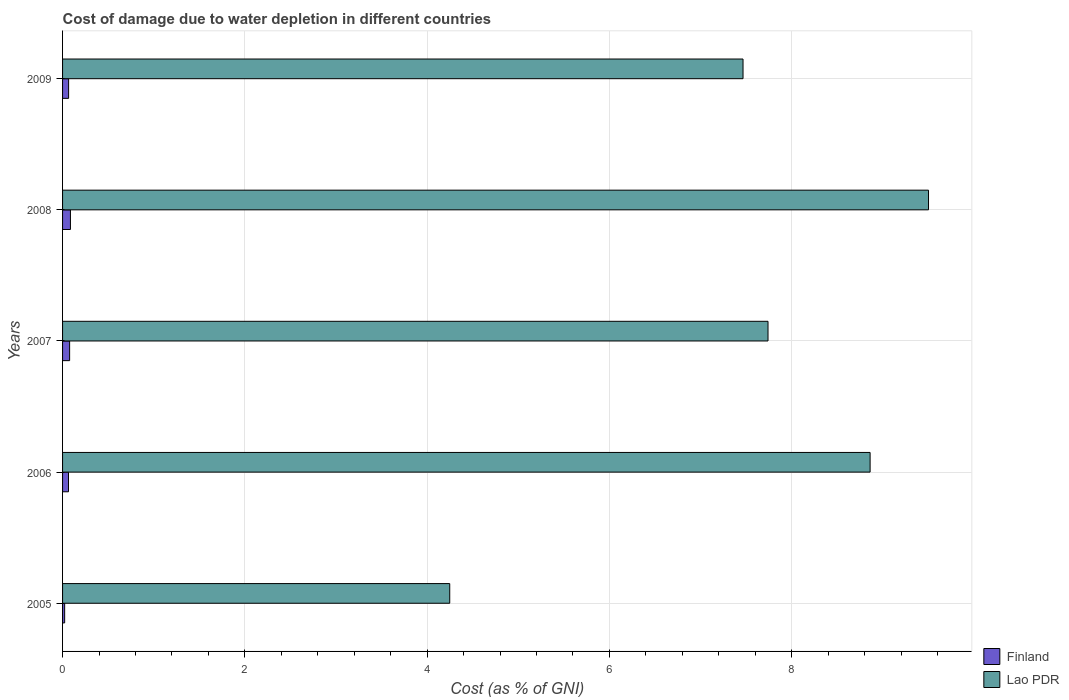How many different coloured bars are there?
Provide a short and direct response. 2. Are the number of bars per tick equal to the number of legend labels?
Offer a terse response. Yes. What is the label of the 4th group of bars from the top?
Offer a very short reply. 2006. In how many cases, is the number of bars for a given year not equal to the number of legend labels?
Keep it short and to the point. 0. What is the cost of damage caused due to water depletion in Lao PDR in 2007?
Make the answer very short. 7.74. Across all years, what is the maximum cost of damage caused due to water depletion in Lao PDR?
Offer a very short reply. 9.5. Across all years, what is the minimum cost of damage caused due to water depletion in Lao PDR?
Give a very brief answer. 4.25. In which year was the cost of damage caused due to water depletion in Lao PDR minimum?
Ensure brevity in your answer.  2005. What is the total cost of damage caused due to water depletion in Lao PDR in the graph?
Your response must be concise. 37.82. What is the difference between the cost of damage caused due to water depletion in Finland in 2005 and that in 2006?
Your answer should be very brief. -0.04. What is the difference between the cost of damage caused due to water depletion in Lao PDR in 2006 and the cost of damage caused due to water depletion in Finland in 2008?
Ensure brevity in your answer.  8.77. What is the average cost of damage caused due to water depletion in Finland per year?
Give a very brief answer. 0.06. In the year 2008, what is the difference between the cost of damage caused due to water depletion in Finland and cost of damage caused due to water depletion in Lao PDR?
Give a very brief answer. -9.42. What is the ratio of the cost of damage caused due to water depletion in Lao PDR in 2006 to that in 2007?
Your answer should be compact. 1.14. Is the cost of damage caused due to water depletion in Finland in 2005 less than that in 2009?
Provide a short and direct response. Yes. What is the difference between the highest and the second highest cost of damage caused due to water depletion in Finland?
Provide a succinct answer. 0.01. What is the difference between the highest and the lowest cost of damage caused due to water depletion in Lao PDR?
Make the answer very short. 5.25. In how many years, is the cost of damage caused due to water depletion in Finland greater than the average cost of damage caused due to water depletion in Finland taken over all years?
Your answer should be very brief. 4. Is the sum of the cost of damage caused due to water depletion in Lao PDR in 2005 and 2008 greater than the maximum cost of damage caused due to water depletion in Finland across all years?
Your answer should be very brief. Yes. What does the 1st bar from the top in 2008 represents?
Your response must be concise. Lao PDR. What does the 1st bar from the bottom in 2006 represents?
Keep it short and to the point. Finland. How many bars are there?
Your answer should be very brief. 10. How many years are there in the graph?
Make the answer very short. 5. Are the values on the major ticks of X-axis written in scientific E-notation?
Ensure brevity in your answer.  No. Does the graph contain any zero values?
Ensure brevity in your answer.  No. Does the graph contain grids?
Keep it short and to the point. Yes. How many legend labels are there?
Keep it short and to the point. 2. What is the title of the graph?
Your response must be concise. Cost of damage due to water depletion in different countries. Does "Sudan" appear as one of the legend labels in the graph?
Offer a very short reply. No. What is the label or title of the X-axis?
Your answer should be very brief. Cost (as % of GNI). What is the label or title of the Y-axis?
Provide a short and direct response. Years. What is the Cost (as % of GNI) in Finland in 2005?
Your response must be concise. 0.02. What is the Cost (as % of GNI) of Lao PDR in 2005?
Your answer should be compact. 4.25. What is the Cost (as % of GNI) in Finland in 2006?
Your response must be concise. 0.07. What is the Cost (as % of GNI) in Lao PDR in 2006?
Your answer should be compact. 8.86. What is the Cost (as % of GNI) of Finland in 2007?
Your response must be concise. 0.08. What is the Cost (as % of GNI) of Lao PDR in 2007?
Your response must be concise. 7.74. What is the Cost (as % of GNI) of Finland in 2008?
Provide a succinct answer. 0.09. What is the Cost (as % of GNI) in Lao PDR in 2008?
Offer a terse response. 9.5. What is the Cost (as % of GNI) in Finland in 2009?
Your answer should be compact. 0.07. What is the Cost (as % of GNI) in Lao PDR in 2009?
Offer a very short reply. 7.47. Across all years, what is the maximum Cost (as % of GNI) of Finland?
Ensure brevity in your answer.  0.09. Across all years, what is the maximum Cost (as % of GNI) of Lao PDR?
Your answer should be very brief. 9.5. Across all years, what is the minimum Cost (as % of GNI) of Finland?
Offer a very short reply. 0.02. Across all years, what is the minimum Cost (as % of GNI) in Lao PDR?
Offer a terse response. 4.25. What is the total Cost (as % of GNI) in Finland in the graph?
Offer a terse response. 0.32. What is the total Cost (as % of GNI) of Lao PDR in the graph?
Keep it short and to the point. 37.82. What is the difference between the Cost (as % of GNI) of Finland in 2005 and that in 2006?
Ensure brevity in your answer.  -0.04. What is the difference between the Cost (as % of GNI) in Lao PDR in 2005 and that in 2006?
Give a very brief answer. -4.61. What is the difference between the Cost (as % of GNI) in Finland in 2005 and that in 2007?
Your answer should be very brief. -0.05. What is the difference between the Cost (as % of GNI) of Lao PDR in 2005 and that in 2007?
Make the answer very short. -3.49. What is the difference between the Cost (as % of GNI) of Finland in 2005 and that in 2008?
Give a very brief answer. -0.06. What is the difference between the Cost (as % of GNI) in Lao PDR in 2005 and that in 2008?
Provide a succinct answer. -5.25. What is the difference between the Cost (as % of GNI) of Finland in 2005 and that in 2009?
Ensure brevity in your answer.  -0.04. What is the difference between the Cost (as % of GNI) of Lao PDR in 2005 and that in 2009?
Offer a terse response. -3.22. What is the difference between the Cost (as % of GNI) in Finland in 2006 and that in 2007?
Keep it short and to the point. -0.01. What is the difference between the Cost (as % of GNI) of Lao PDR in 2006 and that in 2007?
Your answer should be compact. 1.12. What is the difference between the Cost (as % of GNI) of Finland in 2006 and that in 2008?
Your response must be concise. -0.02. What is the difference between the Cost (as % of GNI) of Lao PDR in 2006 and that in 2008?
Make the answer very short. -0.64. What is the difference between the Cost (as % of GNI) of Finland in 2006 and that in 2009?
Your answer should be very brief. -0. What is the difference between the Cost (as % of GNI) in Lao PDR in 2006 and that in 2009?
Give a very brief answer. 1.39. What is the difference between the Cost (as % of GNI) in Finland in 2007 and that in 2008?
Your answer should be compact. -0.01. What is the difference between the Cost (as % of GNI) of Lao PDR in 2007 and that in 2008?
Your response must be concise. -1.76. What is the difference between the Cost (as % of GNI) in Finland in 2007 and that in 2009?
Your answer should be compact. 0.01. What is the difference between the Cost (as % of GNI) of Lao PDR in 2007 and that in 2009?
Provide a succinct answer. 0.27. What is the difference between the Cost (as % of GNI) in Finland in 2008 and that in 2009?
Keep it short and to the point. 0.02. What is the difference between the Cost (as % of GNI) of Lao PDR in 2008 and that in 2009?
Your answer should be very brief. 2.04. What is the difference between the Cost (as % of GNI) in Finland in 2005 and the Cost (as % of GNI) in Lao PDR in 2006?
Ensure brevity in your answer.  -8.84. What is the difference between the Cost (as % of GNI) of Finland in 2005 and the Cost (as % of GNI) of Lao PDR in 2007?
Your response must be concise. -7.72. What is the difference between the Cost (as % of GNI) in Finland in 2005 and the Cost (as % of GNI) in Lao PDR in 2008?
Provide a short and direct response. -9.48. What is the difference between the Cost (as % of GNI) in Finland in 2005 and the Cost (as % of GNI) in Lao PDR in 2009?
Provide a short and direct response. -7.44. What is the difference between the Cost (as % of GNI) in Finland in 2006 and the Cost (as % of GNI) in Lao PDR in 2007?
Your answer should be compact. -7.68. What is the difference between the Cost (as % of GNI) in Finland in 2006 and the Cost (as % of GNI) in Lao PDR in 2008?
Keep it short and to the point. -9.44. What is the difference between the Cost (as % of GNI) in Finland in 2006 and the Cost (as % of GNI) in Lao PDR in 2009?
Offer a terse response. -7.4. What is the difference between the Cost (as % of GNI) of Finland in 2007 and the Cost (as % of GNI) of Lao PDR in 2008?
Offer a terse response. -9.42. What is the difference between the Cost (as % of GNI) of Finland in 2007 and the Cost (as % of GNI) of Lao PDR in 2009?
Ensure brevity in your answer.  -7.39. What is the difference between the Cost (as % of GNI) of Finland in 2008 and the Cost (as % of GNI) of Lao PDR in 2009?
Provide a short and direct response. -7.38. What is the average Cost (as % of GNI) in Finland per year?
Offer a terse response. 0.06. What is the average Cost (as % of GNI) of Lao PDR per year?
Offer a very short reply. 7.56. In the year 2005, what is the difference between the Cost (as % of GNI) in Finland and Cost (as % of GNI) in Lao PDR?
Provide a succinct answer. -4.23. In the year 2006, what is the difference between the Cost (as % of GNI) of Finland and Cost (as % of GNI) of Lao PDR?
Your response must be concise. -8.8. In the year 2007, what is the difference between the Cost (as % of GNI) of Finland and Cost (as % of GNI) of Lao PDR?
Your response must be concise. -7.66. In the year 2008, what is the difference between the Cost (as % of GNI) of Finland and Cost (as % of GNI) of Lao PDR?
Give a very brief answer. -9.42. In the year 2009, what is the difference between the Cost (as % of GNI) of Finland and Cost (as % of GNI) of Lao PDR?
Provide a succinct answer. -7.4. What is the ratio of the Cost (as % of GNI) in Finland in 2005 to that in 2006?
Provide a short and direct response. 0.35. What is the ratio of the Cost (as % of GNI) in Lao PDR in 2005 to that in 2006?
Offer a terse response. 0.48. What is the ratio of the Cost (as % of GNI) of Finland in 2005 to that in 2007?
Offer a terse response. 0.3. What is the ratio of the Cost (as % of GNI) in Lao PDR in 2005 to that in 2007?
Ensure brevity in your answer.  0.55. What is the ratio of the Cost (as % of GNI) of Finland in 2005 to that in 2008?
Your answer should be very brief. 0.27. What is the ratio of the Cost (as % of GNI) of Lao PDR in 2005 to that in 2008?
Ensure brevity in your answer.  0.45. What is the ratio of the Cost (as % of GNI) of Finland in 2005 to that in 2009?
Your answer should be very brief. 0.35. What is the ratio of the Cost (as % of GNI) in Lao PDR in 2005 to that in 2009?
Ensure brevity in your answer.  0.57. What is the ratio of the Cost (as % of GNI) in Finland in 2006 to that in 2007?
Give a very brief answer. 0.84. What is the ratio of the Cost (as % of GNI) in Lao PDR in 2006 to that in 2007?
Make the answer very short. 1.14. What is the ratio of the Cost (as % of GNI) of Finland in 2006 to that in 2008?
Your answer should be very brief. 0.75. What is the ratio of the Cost (as % of GNI) of Lao PDR in 2006 to that in 2008?
Provide a short and direct response. 0.93. What is the ratio of the Cost (as % of GNI) in Finland in 2006 to that in 2009?
Give a very brief answer. 0.98. What is the ratio of the Cost (as % of GNI) in Lao PDR in 2006 to that in 2009?
Provide a succinct answer. 1.19. What is the ratio of the Cost (as % of GNI) of Finland in 2007 to that in 2008?
Keep it short and to the point. 0.9. What is the ratio of the Cost (as % of GNI) of Lao PDR in 2007 to that in 2008?
Ensure brevity in your answer.  0.81. What is the ratio of the Cost (as % of GNI) of Finland in 2007 to that in 2009?
Ensure brevity in your answer.  1.17. What is the ratio of the Cost (as % of GNI) in Lao PDR in 2007 to that in 2009?
Ensure brevity in your answer.  1.04. What is the ratio of the Cost (as % of GNI) of Finland in 2008 to that in 2009?
Your answer should be compact. 1.3. What is the ratio of the Cost (as % of GNI) in Lao PDR in 2008 to that in 2009?
Your answer should be very brief. 1.27. What is the difference between the highest and the second highest Cost (as % of GNI) in Finland?
Offer a terse response. 0.01. What is the difference between the highest and the second highest Cost (as % of GNI) in Lao PDR?
Make the answer very short. 0.64. What is the difference between the highest and the lowest Cost (as % of GNI) of Finland?
Offer a terse response. 0.06. What is the difference between the highest and the lowest Cost (as % of GNI) in Lao PDR?
Your answer should be compact. 5.25. 